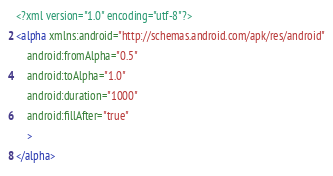Convert code to text. <code><loc_0><loc_0><loc_500><loc_500><_XML_><?xml version="1.0" encoding="utf-8"?>
<alpha xmlns:android="http://schemas.android.com/apk/res/android"
    android:fromAlpha="0.5"
    android:toAlpha="1.0"
    android:duration="1000"
    android:fillAfter="true"
    >
</alpha>

</code> 